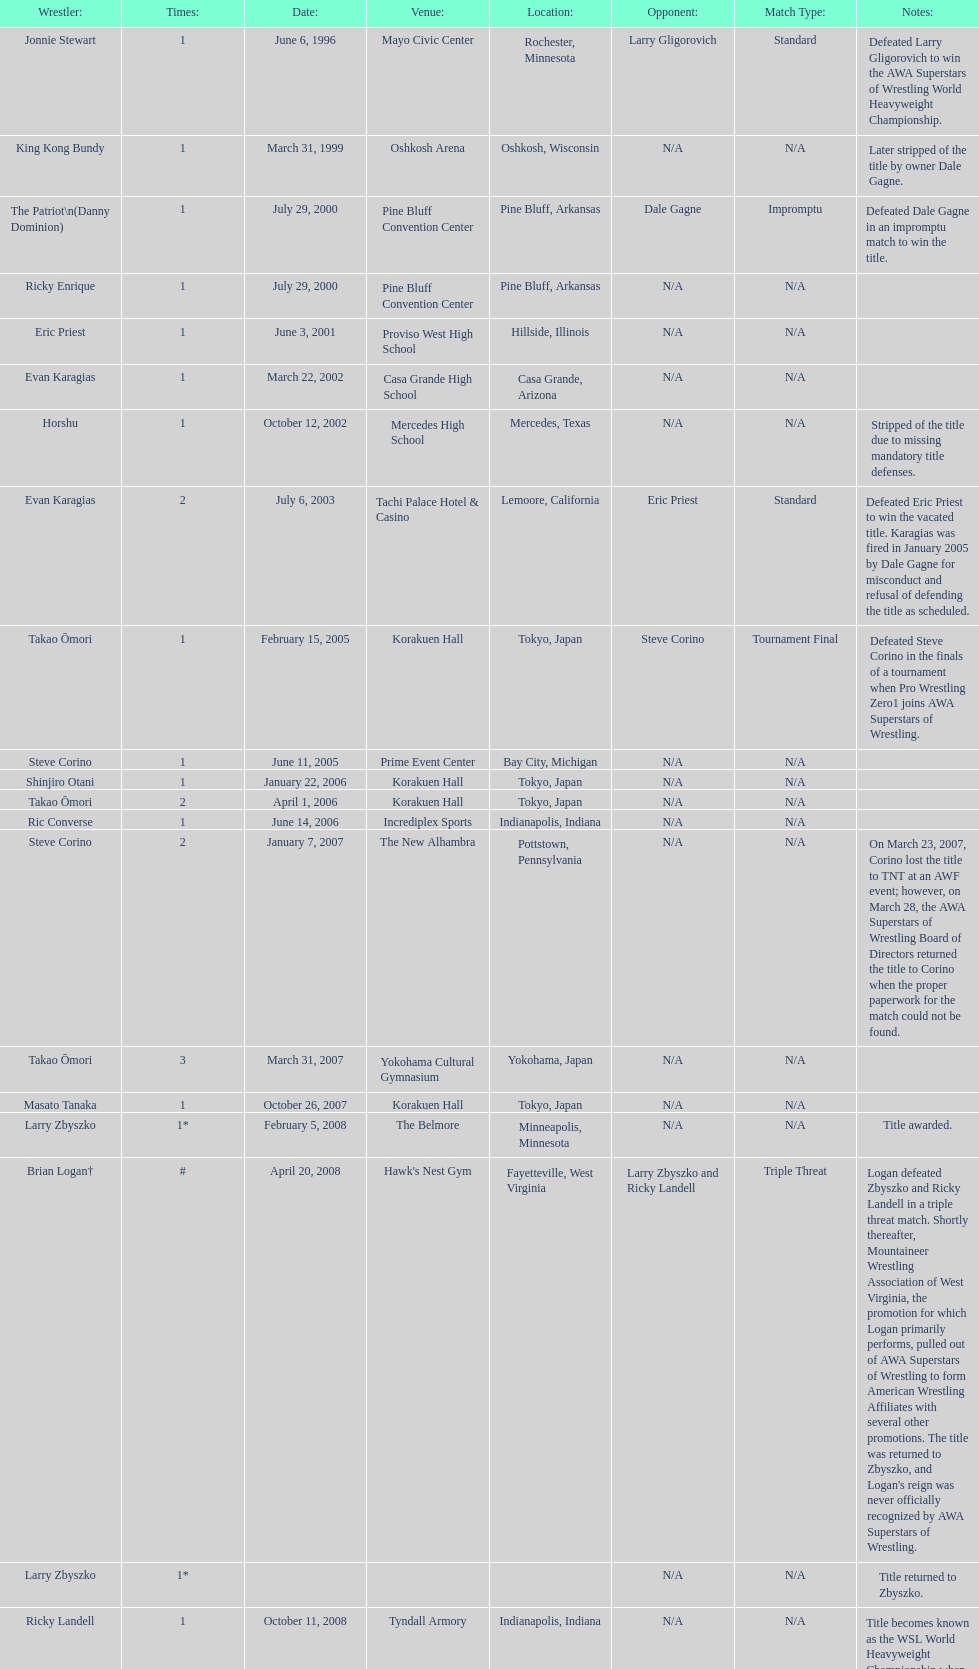How many times has ricky landell held the wsl title? 1. 